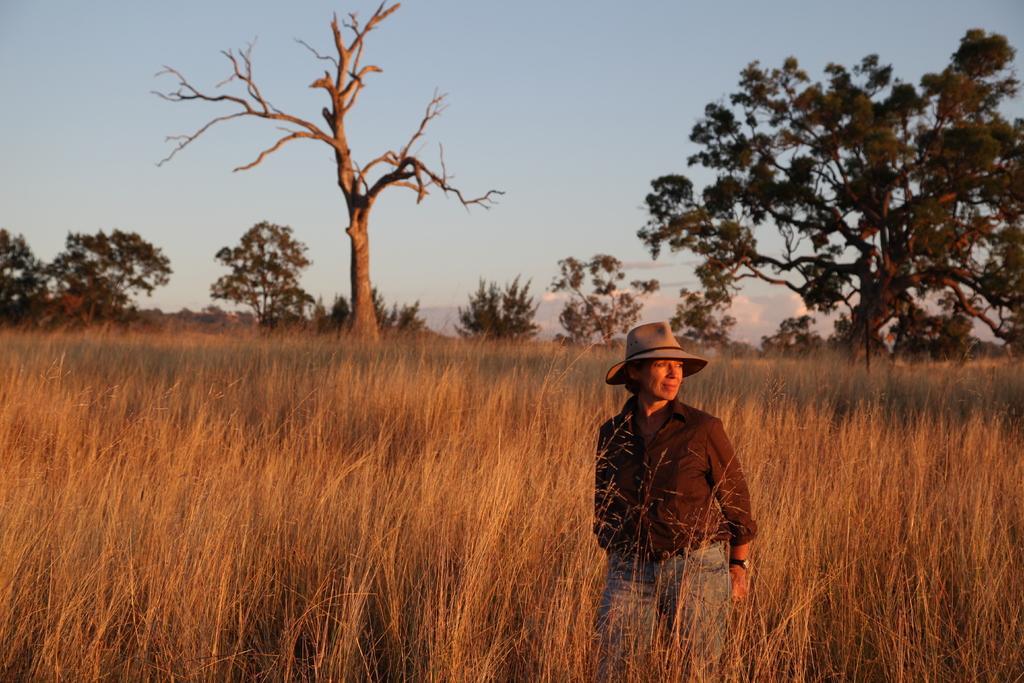Please provide a concise description of this image. In the foreground of the picture we can see a field and a woman. In the middle there are trees. At the top there is sky. 